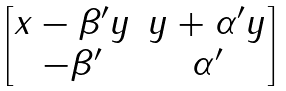Convert formula to latex. <formula><loc_0><loc_0><loc_500><loc_500>\begin{bmatrix} x - \beta ^ { \prime } y & y + \alpha ^ { \prime } y \\ - \beta ^ { \prime } & \alpha ^ { \prime } \end{bmatrix}</formula> 